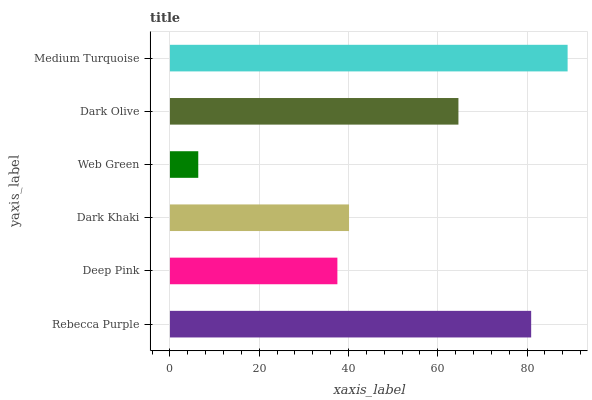Is Web Green the minimum?
Answer yes or no. Yes. Is Medium Turquoise the maximum?
Answer yes or no. Yes. Is Deep Pink the minimum?
Answer yes or no. No. Is Deep Pink the maximum?
Answer yes or no. No. Is Rebecca Purple greater than Deep Pink?
Answer yes or no. Yes. Is Deep Pink less than Rebecca Purple?
Answer yes or no. Yes. Is Deep Pink greater than Rebecca Purple?
Answer yes or no. No. Is Rebecca Purple less than Deep Pink?
Answer yes or no. No. Is Dark Olive the high median?
Answer yes or no. Yes. Is Dark Khaki the low median?
Answer yes or no. Yes. Is Web Green the high median?
Answer yes or no. No. Is Web Green the low median?
Answer yes or no. No. 